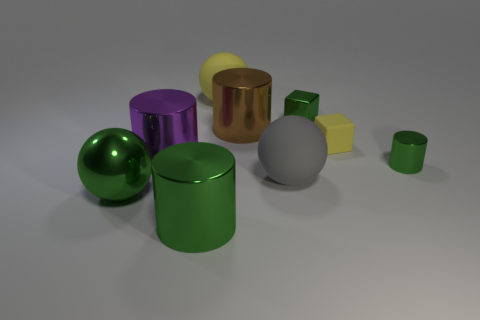Does the metal thing in front of the metal ball have the same size as the big green shiny ball?
Give a very brief answer. Yes. There is a big rubber object that is on the right side of the brown shiny thing; what shape is it?
Offer a terse response. Sphere. Are there more yellow rubber cubes than brown spheres?
Provide a short and direct response. Yes. There is a cylinder in front of the gray ball; is its color the same as the small metallic cylinder?
Make the answer very short. Yes. What number of objects are either big green metallic cylinders to the right of the shiny ball or shiny cylinders that are on the right side of the metallic block?
Your answer should be very brief. 2. What number of spheres are behind the big brown object and in front of the tiny green block?
Make the answer very short. 0. Does the gray thing have the same material as the brown cylinder?
Ensure brevity in your answer.  No. There is a large rubber thing on the right side of the yellow rubber thing that is behind the tiny green metal object to the left of the small metallic cylinder; what is its shape?
Your answer should be compact. Sphere. What is the material of the cylinder that is to the left of the green metal block and in front of the purple cylinder?
Provide a succinct answer. Metal. There is a small metal thing that is to the left of the small metallic object in front of the metallic cylinder behind the purple metal thing; what color is it?
Make the answer very short. Green. 